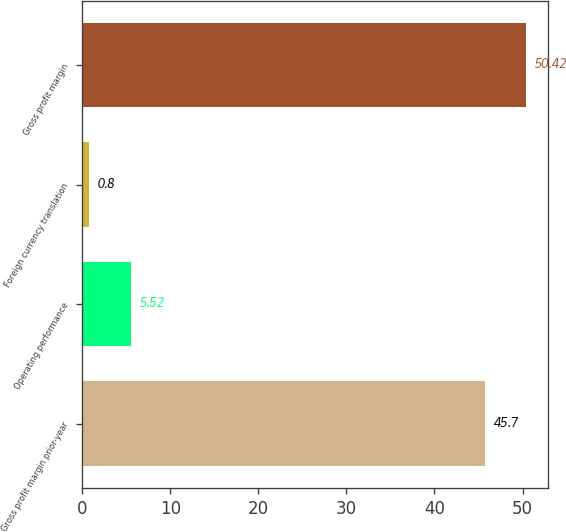Convert chart to OTSL. <chart><loc_0><loc_0><loc_500><loc_500><bar_chart><fcel>Gross profit margin prior-year<fcel>Operating performance<fcel>Foreign currency translation<fcel>Gross profit margin<nl><fcel>45.7<fcel>5.52<fcel>0.8<fcel>50.42<nl></chart> 